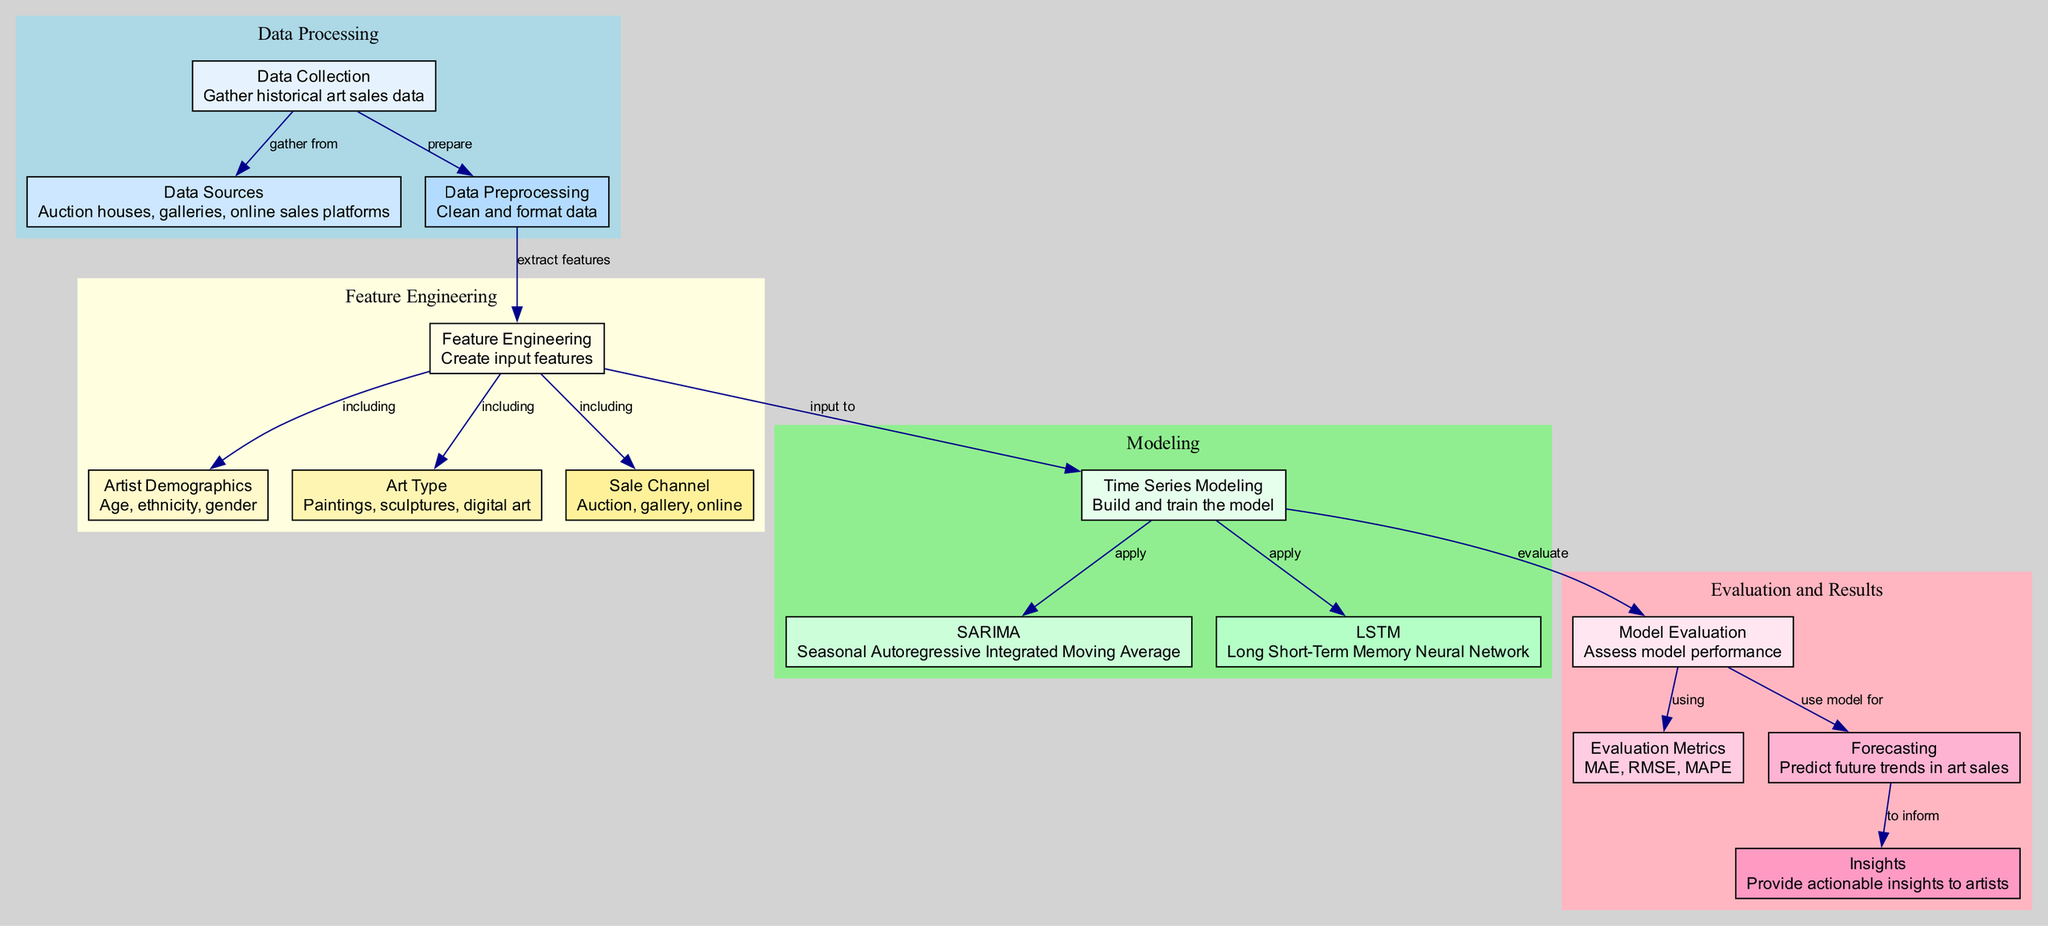What is the first step in the diagram? The first step in the diagram is "Data Collection", which involves gathering historical art sales data. This is evident from the position of this node at the top of the flow.
Answer: Data Collection How many features are included in the feature engineering step? There are three features included: Artist Demographics, Art Type, and Sale Channel. This can be determined by counting the edges leading from the Feature Engineering node to each of these feature nodes.
Answer: Three What type of model is applied after time series modeling? The models applied after time series modeling are SARIMA and LSTM. This is direct from the edges connecting the Time Series Modeling node to each of the model nodes.
Answer: SARIMA and LSTM Which node evaluates the model's performance? The node that evaluates the model's performance is "Model Evaluation". This is indicated by the connection from the Time Series Modeling node to the Model Evaluation node.
Answer: Model Evaluation What insights can be derived from the forecasting step? The insights generated are actionable insights for artists. This can be seen from the connection between the Forecasting node and the Insights node.
Answer: Actionable insights How does data preprocessing relate to feature engineering? Data preprocessing provides cleaned and formatted data that is used to extract features in the feature engineering step. This is shown by the edge from Data Preprocessing to Feature Engineering.
Answer: Data preprocessing prepares the data for feature engineering What are the evaluation metrics used in the model evaluation step? The evaluation metrics used are MAE, RMSE, and MAPE, as indicated by the edge leading from the Model Evaluation node to the Metrics node.
Answer: MAE, RMSE, MAPE Which nodes are categorized under "Feature Engineering"? The nodes under Feature Engineering include Feature Engineering itself, Artist Demographics, Art Type, and Sale Channel. They are grouped together in the diagram indicating they belong to the same category.
Answer: Feature Engineering, Artist Demographics, Art Type, Sale Channel What is the final outcome of the diagram's process? The final outcome of the process is to provide insights based on the forecasting of future trends in art sales. This is indicated by the connection from the Forecasting node to the Insights node.
Answer: Insights 